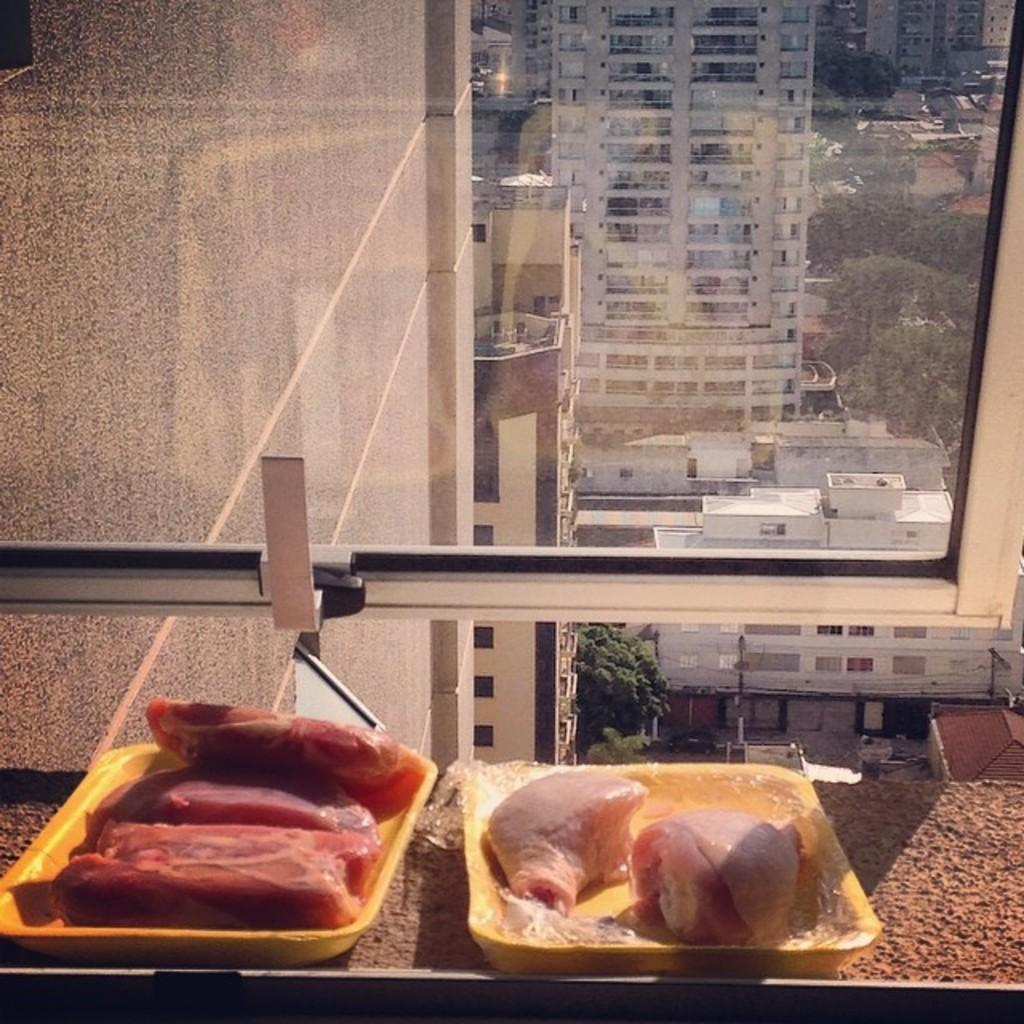How many plates are visible in the image? There are two plates in the image. Where are the plates located in relation to other elements in the image? The plates are near a window. What is on the plates? The plates have meat on them. What can be seen in the background of the image? There are buildings and trees in the background of the image. How many jellyfish are visible in the image? There are no jellyfish present in the image. Is there a form of transportation visible in the image? The provided facts do not mention any form of transportation in the image. 